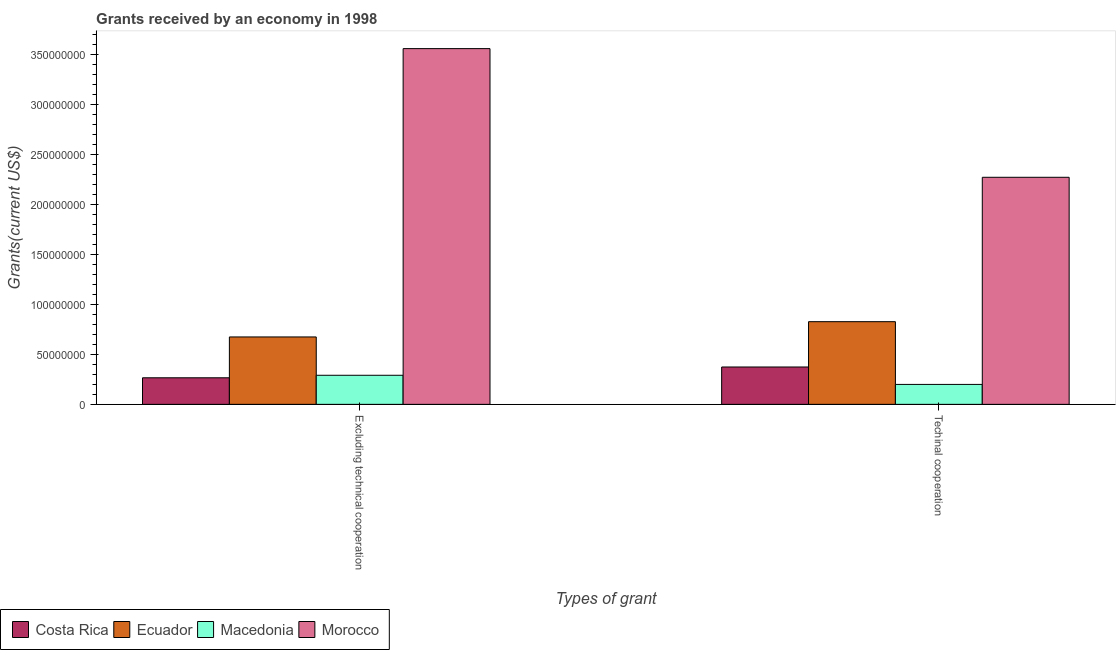Are the number of bars on each tick of the X-axis equal?
Offer a very short reply. Yes. How many bars are there on the 1st tick from the left?
Give a very brief answer. 4. What is the label of the 2nd group of bars from the left?
Make the answer very short. Techinal cooperation. What is the amount of grants received(including technical cooperation) in Costa Rica?
Keep it short and to the point. 3.74e+07. Across all countries, what is the maximum amount of grants received(excluding technical cooperation)?
Your answer should be very brief. 3.56e+08. Across all countries, what is the minimum amount of grants received(including technical cooperation)?
Offer a very short reply. 1.99e+07. In which country was the amount of grants received(excluding technical cooperation) maximum?
Give a very brief answer. Morocco. In which country was the amount of grants received(including technical cooperation) minimum?
Keep it short and to the point. Macedonia. What is the total amount of grants received(excluding technical cooperation) in the graph?
Give a very brief answer. 4.79e+08. What is the difference between the amount of grants received(including technical cooperation) in Morocco and that in Ecuador?
Give a very brief answer. 1.44e+08. What is the difference between the amount of grants received(excluding technical cooperation) in Macedonia and the amount of grants received(including technical cooperation) in Ecuador?
Make the answer very short. -5.36e+07. What is the average amount of grants received(excluding technical cooperation) per country?
Make the answer very short. 1.20e+08. What is the difference between the amount of grants received(including technical cooperation) and amount of grants received(excluding technical cooperation) in Morocco?
Offer a very short reply. -1.29e+08. In how many countries, is the amount of grants received(including technical cooperation) greater than 180000000 US$?
Offer a very short reply. 1. What is the ratio of the amount of grants received(excluding technical cooperation) in Costa Rica to that in Macedonia?
Your answer should be compact. 0.91. In how many countries, is the amount of grants received(excluding technical cooperation) greater than the average amount of grants received(excluding technical cooperation) taken over all countries?
Make the answer very short. 1. What does the 3rd bar from the left in Excluding technical cooperation represents?
Offer a terse response. Macedonia. What does the 4th bar from the right in Techinal cooperation represents?
Your answer should be compact. Costa Rica. How many bars are there?
Give a very brief answer. 8. Are all the bars in the graph horizontal?
Your response must be concise. No. Are the values on the major ticks of Y-axis written in scientific E-notation?
Your response must be concise. No. Does the graph contain any zero values?
Ensure brevity in your answer.  No. Where does the legend appear in the graph?
Provide a short and direct response. Bottom left. How many legend labels are there?
Provide a short and direct response. 4. What is the title of the graph?
Offer a terse response. Grants received by an economy in 1998. What is the label or title of the X-axis?
Give a very brief answer. Types of grant. What is the label or title of the Y-axis?
Keep it short and to the point. Grants(current US$). What is the Grants(current US$) of Costa Rica in Excluding technical cooperation?
Provide a succinct answer. 2.66e+07. What is the Grants(current US$) of Ecuador in Excluding technical cooperation?
Your response must be concise. 6.74e+07. What is the Grants(current US$) of Macedonia in Excluding technical cooperation?
Make the answer very short. 2.91e+07. What is the Grants(current US$) of Morocco in Excluding technical cooperation?
Your answer should be compact. 3.56e+08. What is the Grants(current US$) of Costa Rica in Techinal cooperation?
Your response must be concise. 3.74e+07. What is the Grants(current US$) in Ecuador in Techinal cooperation?
Your answer should be compact. 8.26e+07. What is the Grants(current US$) in Macedonia in Techinal cooperation?
Offer a very short reply. 1.99e+07. What is the Grants(current US$) in Morocco in Techinal cooperation?
Offer a terse response. 2.27e+08. Across all Types of grant, what is the maximum Grants(current US$) in Costa Rica?
Ensure brevity in your answer.  3.74e+07. Across all Types of grant, what is the maximum Grants(current US$) of Ecuador?
Provide a short and direct response. 8.26e+07. Across all Types of grant, what is the maximum Grants(current US$) of Macedonia?
Give a very brief answer. 2.91e+07. Across all Types of grant, what is the maximum Grants(current US$) in Morocco?
Keep it short and to the point. 3.56e+08. Across all Types of grant, what is the minimum Grants(current US$) in Costa Rica?
Provide a short and direct response. 2.66e+07. Across all Types of grant, what is the minimum Grants(current US$) of Ecuador?
Provide a short and direct response. 6.74e+07. Across all Types of grant, what is the minimum Grants(current US$) in Macedonia?
Provide a short and direct response. 1.99e+07. Across all Types of grant, what is the minimum Grants(current US$) in Morocco?
Your answer should be compact. 2.27e+08. What is the total Grants(current US$) of Costa Rica in the graph?
Offer a very short reply. 6.39e+07. What is the total Grants(current US$) of Ecuador in the graph?
Offer a terse response. 1.50e+08. What is the total Grants(current US$) in Macedonia in the graph?
Make the answer very short. 4.90e+07. What is the total Grants(current US$) in Morocco in the graph?
Give a very brief answer. 5.82e+08. What is the difference between the Grants(current US$) in Costa Rica in Excluding technical cooperation and that in Techinal cooperation?
Your response must be concise. -1.08e+07. What is the difference between the Grants(current US$) of Ecuador in Excluding technical cooperation and that in Techinal cooperation?
Offer a very short reply. -1.53e+07. What is the difference between the Grants(current US$) in Macedonia in Excluding technical cooperation and that in Techinal cooperation?
Your answer should be compact. 9.14e+06. What is the difference between the Grants(current US$) of Morocco in Excluding technical cooperation and that in Techinal cooperation?
Offer a very short reply. 1.29e+08. What is the difference between the Grants(current US$) of Costa Rica in Excluding technical cooperation and the Grants(current US$) of Ecuador in Techinal cooperation?
Keep it short and to the point. -5.61e+07. What is the difference between the Grants(current US$) in Costa Rica in Excluding technical cooperation and the Grants(current US$) in Macedonia in Techinal cooperation?
Provide a short and direct response. 6.62e+06. What is the difference between the Grants(current US$) of Costa Rica in Excluding technical cooperation and the Grants(current US$) of Morocco in Techinal cooperation?
Provide a short and direct response. -2.00e+08. What is the difference between the Grants(current US$) of Ecuador in Excluding technical cooperation and the Grants(current US$) of Macedonia in Techinal cooperation?
Ensure brevity in your answer.  4.74e+07. What is the difference between the Grants(current US$) of Ecuador in Excluding technical cooperation and the Grants(current US$) of Morocco in Techinal cooperation?
Keep it short and to the point. -1.60e+08. What is the difference between the Grants(current US$) of Macedonia in Excluding technical cooperation and the Grants(current US$) of Morocco in Techinal cooperation?
Your answer should be compact. -1.98e+08. What is the average Grants(current US$) in Costa Rica per Types of grant?
Provide a succinct answer. 3.20e+07. What is the average Grants(current US$) of Ecuador per Types of grant?
Give a very brief answer. 7.50e+07. What is the average Grants(current US$) in Macedonia per Types of grant?
Keep it short and to the point. 2.45e+07. What is the average Grants(current US$) of Morocco per Types of grant?
Ensure brevity in your answer.  2.91e+08. What is the difference between the Grants(current US$) in Costa Rica and Grants(current US$) in Ecuador in Excluding technical cooperation?
Your response must be concise. -4.08e+07. What is the difference between the Grants(current US$) of Costa Rica and Grants(current US$) of Macedonia in Excluding technical cooperation?
Provide a succinct answer. -2.52e+06. What is the difference between the Grants(current US$) of Costa Rica and Grants(current US$) of Morocco in Excluding technical cooperation?
Keep it short and to the point. -3.29e+08. What is the difference between the Grants(current US$) in Ecuador and Grants(current US$) in Macedonia in Excluding technical cooperation?
Your response must be concise. 3.83e+07. What is the difference between the Grants(current US$) in Ecuador and Grants(current US$) in Morocco in Excluding technical cooperation?
Make the answer very short. -2.88e+08. What is the difference between the Grants(current US$) of Macedonia and Grants(current US$) of Morocco in Excluding technical cooperation?
Provide a succinct answer. -3.26e+08. What is the difference between the Grants(current US$) of Costa Rica and Grants(current US$) of Ecuador in Techinal cooperation?
Make the answer very short. -4.53e+07. What is the difference between the Grants(current US$) of Costa Rica and Grants(current US$) of Macedonia in Techinal cooperation?
Offer a very short reply. 1.74e+07. What is the difference between the Grants(current US$) of Costa Rica and Grants(current US$) of Morocco in Techinal cooperation?
Your response must be concise. -1.90e+08. What is the difference between the Grants(current US$) of Ecuador and Grants(current US$) of Macedonia in Techinal cooperation?
Keep it short and to the point. 6.27e+07. What is the difference between the Grants(current US$) in Ecuador and Grants(current US$) in Morocco in Techinal cooperation?
Give a very brief answer. -1.44e+08. What is the difference between the Grants(current US$) in Macedonia and Grants(current US$) in Morocco in Techinal cooperation?
Offer a terse response. -2.07e+08. What is the ratio of the Grants(current US$) in Costa Rica in Excluding technical cooperation to that in Techinal cooperation?
Ensure brevity in your answer.  0.71. What is the ratio of the Grants(current US$) of Ecuador in Excluding technical cooperation to that in Techinal cooperation?
Your answer should be very brief. 0.82. What is the ratio of the Grants(current US$) of Macedonia in Excluding technical cooperation to that in Techinal cooperation?
Make the answer very short. 1.46. What is the ratio of the Grants(current US$) in Morocco in Excluding technical cooperation to that in Techinal cooperation?
Provide a short and direct response. 1.57. What is the difference between the highest and the second highest Grants(current US$) of Costa Rica?
Provide a short and direct response. 1.08e+07. What is the difference between the highest and the second highest Grants(current US$) of Ecuador?
Provide a short and direct response. 1.53e+07. What is the difference between the highest and the second highest Grants(current US$) of Macedonia?
Keep it short and to the point. 9.14e+06. What is the difference between the highest and the second highest Grants(current US$) in Morocco?
Offer a terse response. 1.29e+08. What is the difference between the highest and the lowest Grants(current US$) in Costa Rica?
Provide a succinct answer. 1.08e+07. What is the difference between the highest and the lowest Grants(current US$) in Ecuador?
Provide a short and direct response. 1.53e+07. What is the difference between the highest and the lowest Grants(current US$) of Macedonia?
Ensure brevity in your answer.  9.14e+06. What is the difference between the highest and the lowest Grants(current US$) of Morocco?
Offer a very short reply. 1.29e+08. 